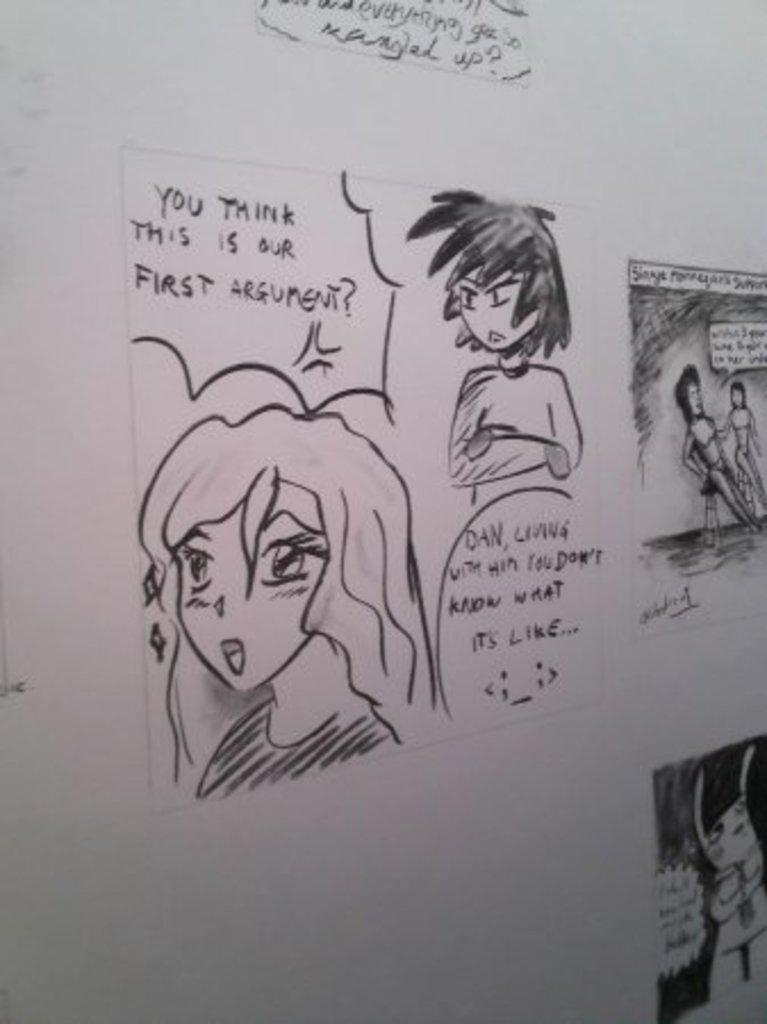Who is present in the image? There are people in the image. What are the people doing in the image? The people are sketching. What can be seen on the white surface in the image? There is text on a white surface in the image. What type of pencil is being used by the person in the image? There is no specific mention of a pencil being used in the image; the people are simply sketching. 